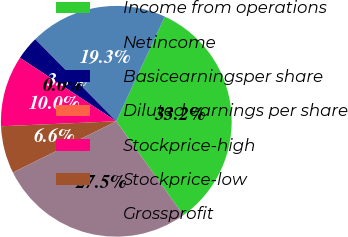Convert chart. <chart><loc_0><loc_0><loc_500><loc_500><pie_chart><fcel>Income from operations<fcel>Netincome<fcel>Basicearningsper share<fcel>Diluted earnings per share<fcel>Stockprice-high<fcel>Stockprice-low<fcel>Grossprofit<nl><fcel>33.21%<fcel>19.32%<fcel>3.32%<fcel>0.0%<fcel>9.96%<fcel>6.64%<fcel>27.55%<nl></chart> 